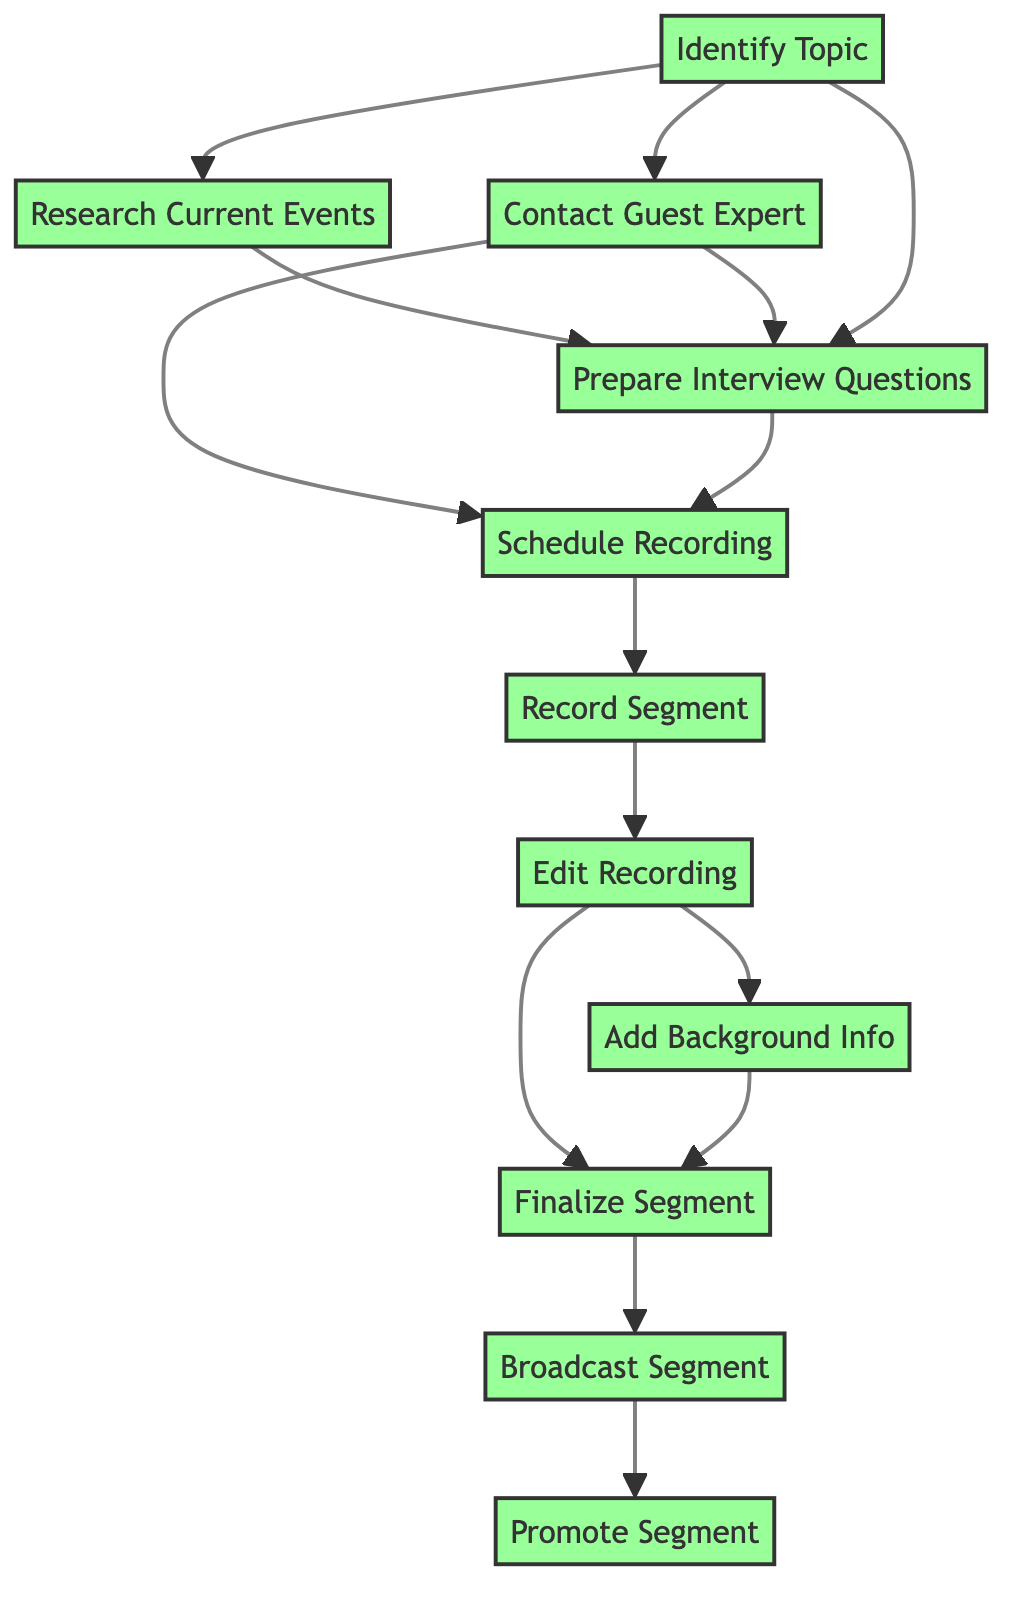What is the first step in creating the radio segment? The first step identified in the diagram is "Identify Topic." This node starts the workflow before any other steps can be taken.
Answer: Identify Topic How many total steps are shown in the diagram? The diagram lists a total of 11 steps from "Identify Topic" to "Promote Segment," counting each distinct activity.
Answer: 11 What two steps depend on "Contact Guest Expert"? The steps that depend on "Contact Guest Expert" are "Schedule Recording" and "Prepare Interview Questions." Both require this step to be completed first before proceeding.
Answer: Schedule Recording, Prepare Interview Questions Which step follows "Edit Recording"? The next step that follows "Edit Recording" is "Add Background Info." This is directly indicated as the subsequent action in the flow.
Answer: Add Background Info What is required before "Finalize Segment"? Before "Finalize Segment," both "Edit Recording" and "Add Background Info" must be completed. This is shown by the dependence structure in the flow chart.
Answer: Edit Recording, Add Background Info What are the last two steps in the workflow? The last two steps in the workflow are "Broadcast Segment" and "Promote Segment." These steps occur at the very end of the process.
Answer: Broadcast Segment, Promote Segment Which step does not have any dependencies? The step "Identify Topic" does not have any dependencies, meaning it is the starting point of the entire process.
Answer: Identify Topic How many steps rely on "Research Current Events"? Only one step, "Prepare Interview Questions," relies on "Research Current Events," indicating its importance in drafting questions.
Answer: 1 What is the relationship between "Schedule Recording" and "Record Segment"? "Schedule Recording" must be completed before moving on to "Record Segment," making this a direct sequential relationship in the workflow.
Answer: Sequential relationship What is necessary before promoting the segment? It is necessary to "Broadcast Segment" before moving on to "Promote Segment," showing that broadcasting must happen first.
Answer: Broadcast Segment 